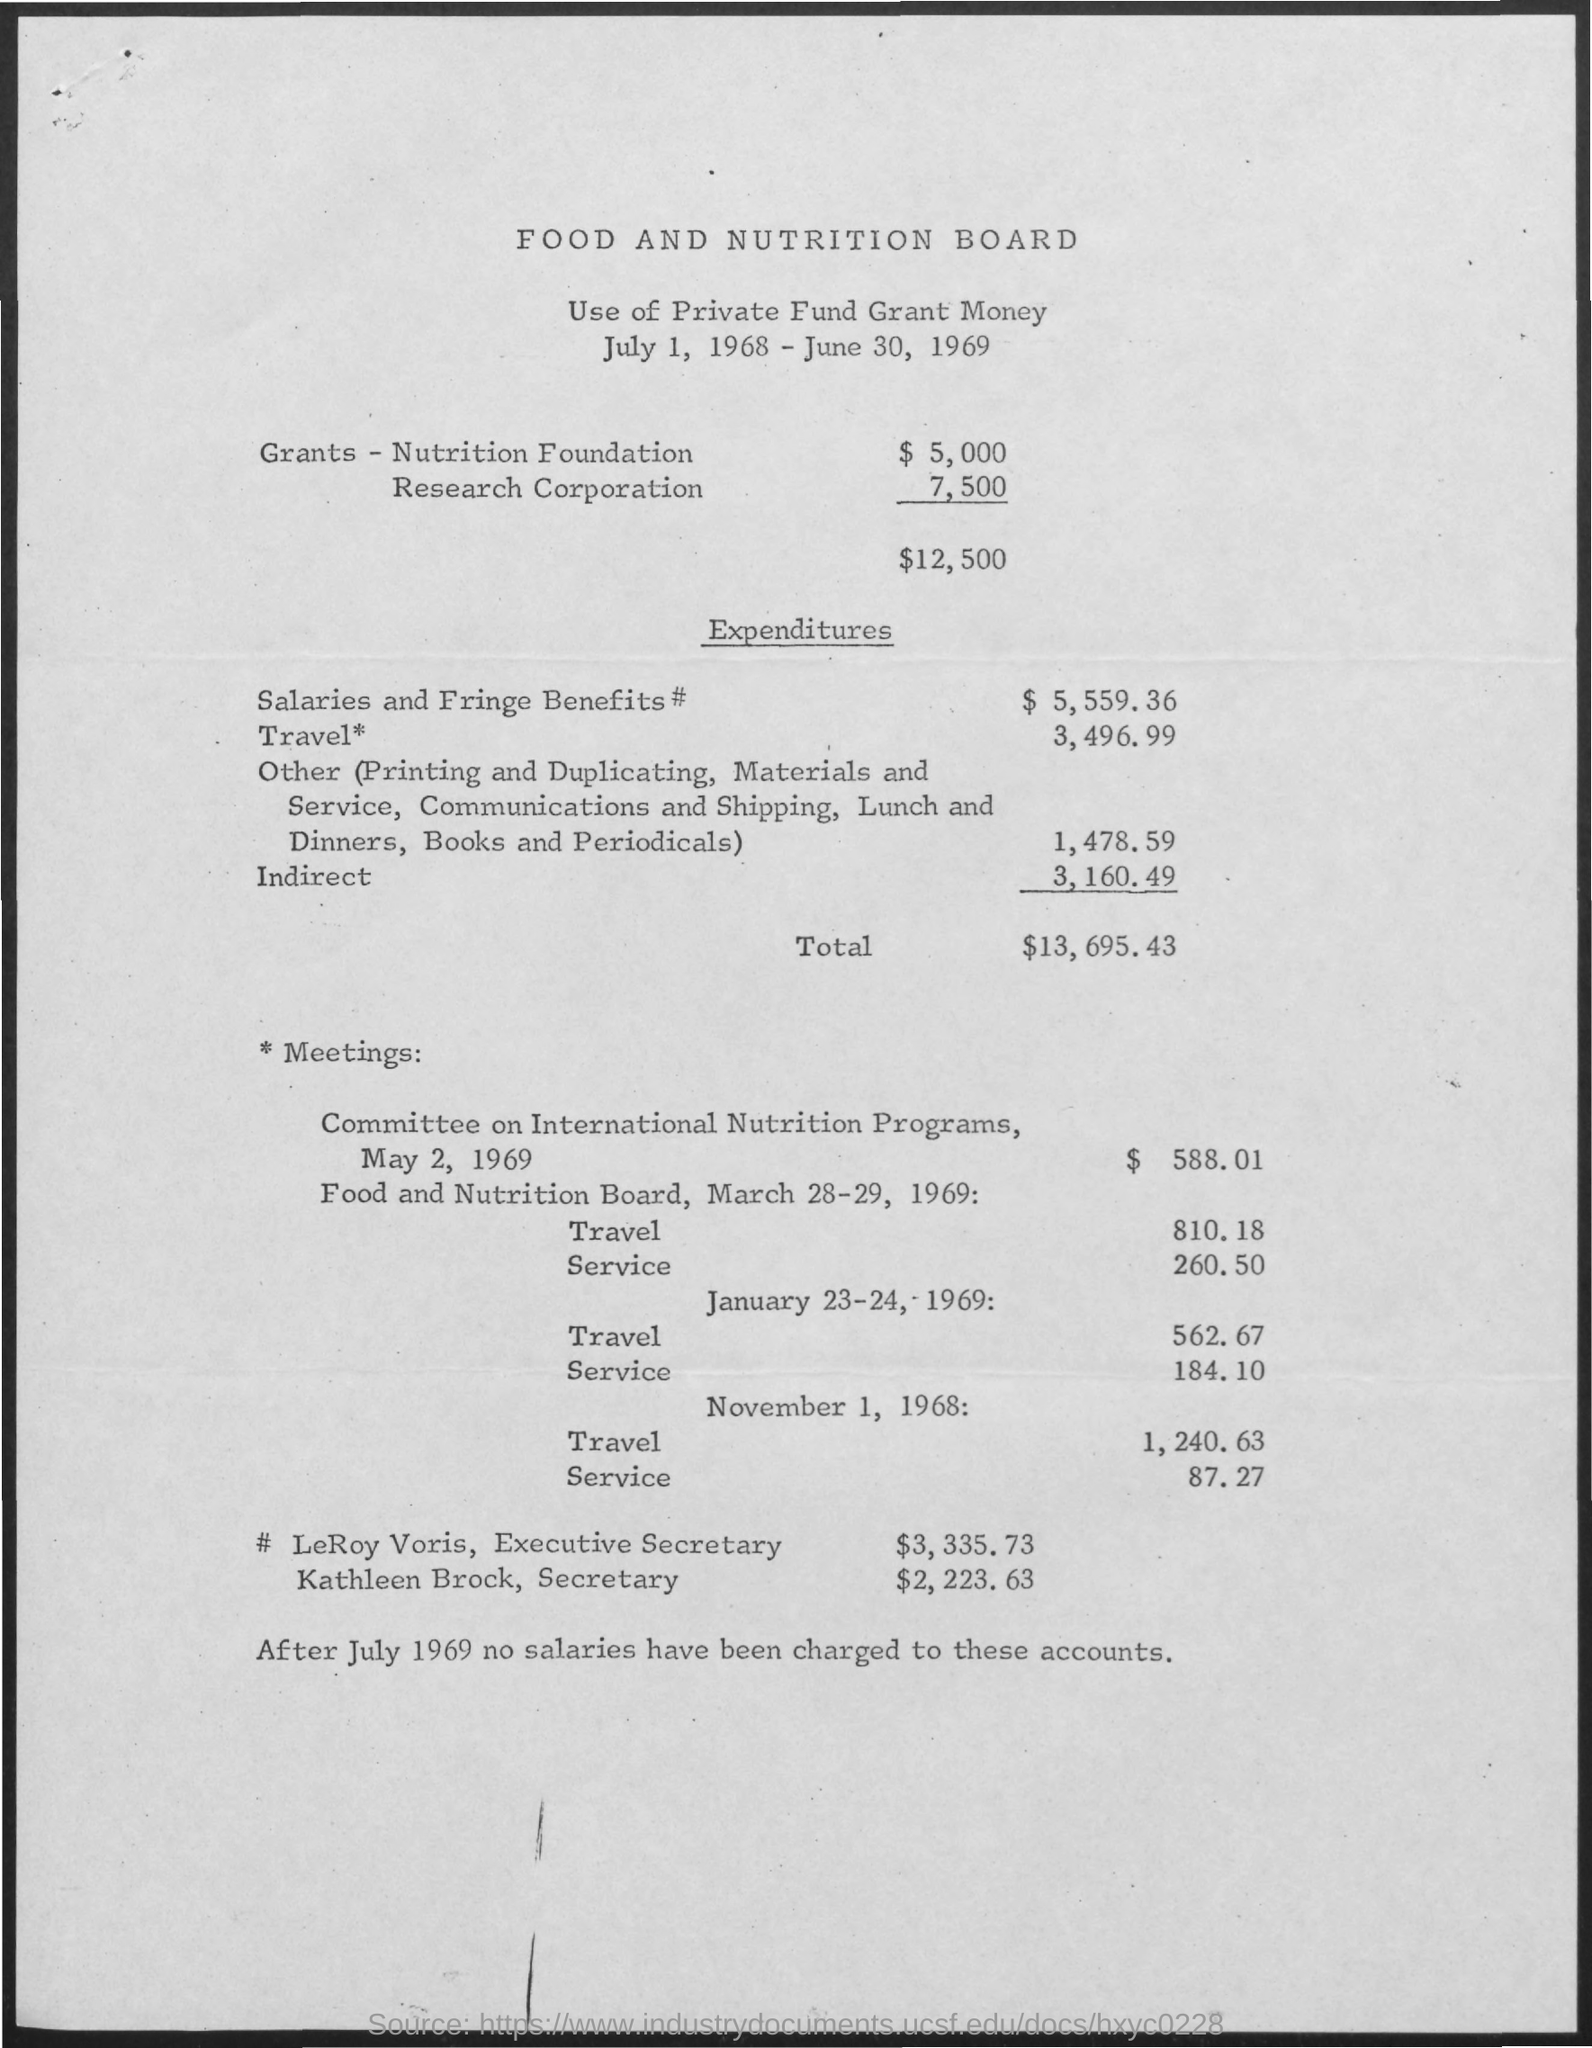What is the date on the document?
Make the answer very short. July 1, 1968 - June 30, 1969. No salaries have been charged after when?
Ensure brevity in your answer.  July 1969. What is the expenditures for Salaries and fringe benefits?
Your answer should be compact. $5,559.36. What is the expenditures for Travel?
Offer a very short reply. 3,496.99. What is the expenditures for other?
Give a very brief answer. 1,478.59. What is the Indirect expenditures?
Offer a terse response. 3,160.49. What are the total expenditures?
Provide a short and direct response. $13,695.43. What is the Total grants?
Provide a succinct answer. $12,500. 